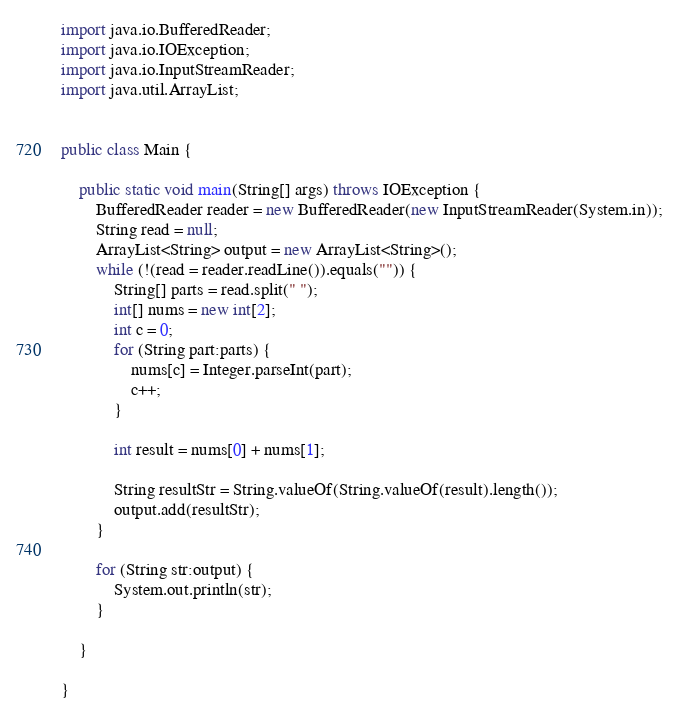Convert code to text. <code><loc_0><loc_0><loc_500><loc_500><_Java_>import java.io.BufferedReader;
import java.io.IOException;
import java.io.InputStreamReader;
import java.util.ArrayList;


public class Main {

	public static void main(String[] args) throws IOException {
		BufferedReader reader = new BufferedReader(new InputStreamReader(System.in));
		String read = null;
		ArrayList<String> output = new ArrayList<String>();
		while (!(read = reader.readLine()).equals("")) {
			String[] parts = read.split(" ");
			int[] nums = new int[2];
			int c = 0;
			for (String part:parts) {
				nums[c] = Integer.parseInt(part);
				c++;
			}

			int result = nums[0] + nums[1];

			String resultStr = String.valueOf(String.valueOf(result).length());
			output.add(resultStr);
		}

		for (String str:output) {
			System.out.println(str);
		}

	}

}</code> 